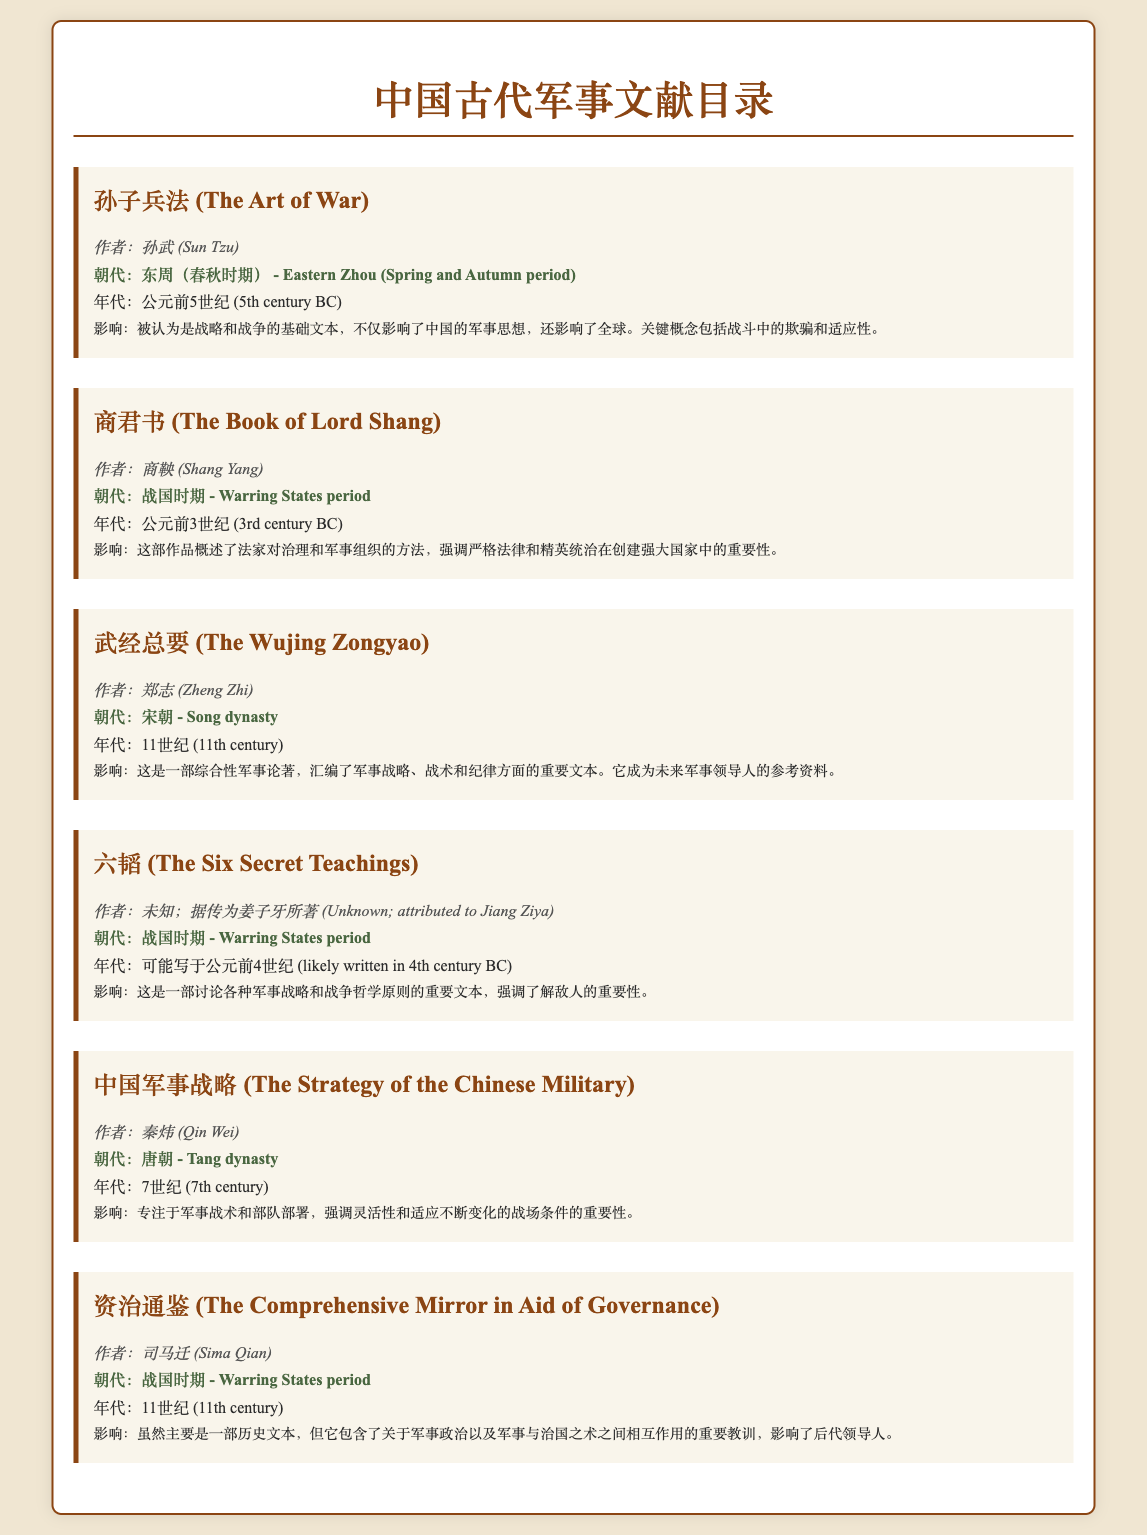What is the title of the influential text by Sun Tzu? The title of the influential text by Sun Tzu is presented at the beginning of the catalog item about him.
Answer: 孙子兵法 (The Art of War) Which dynasty is associated with the Book of Lord Shang? The dynasty is noted in the section that details the author and context of the Book of Lord Shang.
Answer: 战国时期 (Warring States period) Who authored the Wujing Zongyao? The author of the Wujing Zongyao is mentioned directly under the title in its catalog item.
Answer: 郑志 (Zheng Zhi) What century was The Six Secret Teachings likely written in? The probable century of writing is stated in the catalog item describing The Six Secret Teachings.
Answer: 公元前4世纪 (4th century BC) What major concept does The Art of War emphasize? The catalog item summarizes key concepts in The Art of War, leading to the identification of its major themes.
Answer: 战斗中的欺骗和适应性 (deception and adaptability in combat) Explain the significance of the text by Qin Wei in one phrase. The significance is captured in the impact section of the item concerning the text by Qin Wei.
Answer: 强调灵活性和适应变化 (emphasizing flexibility and adaptation) What is the impact of the Comprehensive Mirror in Aid of Governance? The impact is specified in the section relating to the Comprehensive Mirror in Aid of Governance in the catalog.
Answer: 军事政治的重大教训 (important lessons on military politics) Which author is attributed to having written a military text in the Tang dynasty? This information is derived from the catalog item's author details for the Tang dynasty text.
Answer: 秦炜 (Qin Wei) 